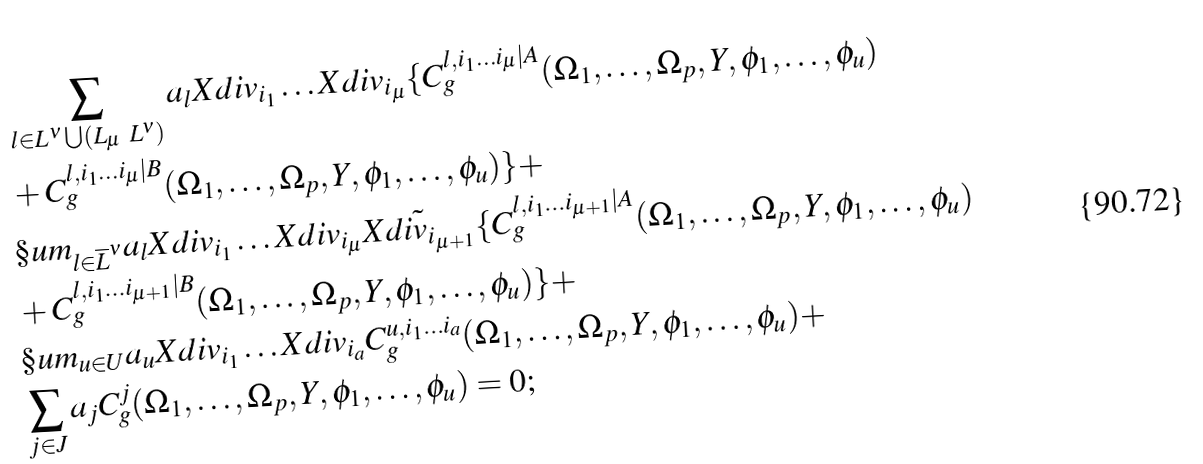<formula> <loc_0><loc_0><loc_500><loc_500>& \sum _ { l \in L ^ { \nu } \bigcup ( L _ { \mu } \ L ^ { \nu } ) } a _ { l } X d i v _ { i _ { 1 } } \dots X d i v _ { i _ { \mu } } \{ C ^ { l , i _ { 1 } \dots i _ { \mu } | A } _ { g } ( \Omega _ { 1 } , \dots , \Omega _ { p } , Y , \phi _ { 1 } , \dots , \phi _ { u } ) \\ & + C ^ { l , i _ { 1 } \dots i _ { \mu } | B } _ { g } ( \Omega _ { 1 } , \dots , \Omega _ { p } , Y , \phi _ { 1 } , \dots , \phi _ { u } ) \} + \\ & \S u m _ { l \in \overline { L } ^ { \nu } } a _ { l } X d i v _ { i _ { 1 } } \dots X d i v _ { i _ { \mu } } \tilde { X d i v _ { i _ { \mu + 1 } } } \{ C ^ { l , i _ { 1 } \dots i _ { \mu + 1 } | A } _ { g } ( \Omega _ { 1 } , \dots , \Omega _ { p } , Y , \phi _ { 1 } , \dots , \phi _ { u } ) \\ & + C ^ { l , i _ { 1 } \dots i _ { \mu + 1 } | B } _ { g } ( \Omega _ { 1 } , \dots , \Omega _ { p } , Y , \phi _ { 1 } , \dots , \phi _ { u } ) \} + \\ & \S u m _ { u \in U } a _ { u } X d i v _ { i _ { 1 } } \dots X d i v _ { i _ { a } } C ^ { u , i _ { 1 } \dots i _ { a } } _ { g } ( \Omega _ { 1 } , \dots , \Omega _ { p } , Y , \phi _ { 1 } , \dots , \phi _ { u } ) + \\ & \sum _ { j \in J } a _ { j } C ^ { j } _ { g } ( \Omega _ { 1 } , \dots , \Omega _ { p } , Y , \phi _ { 1 } , \dots , \phi _ { u } ) = 0 ;</formula> 